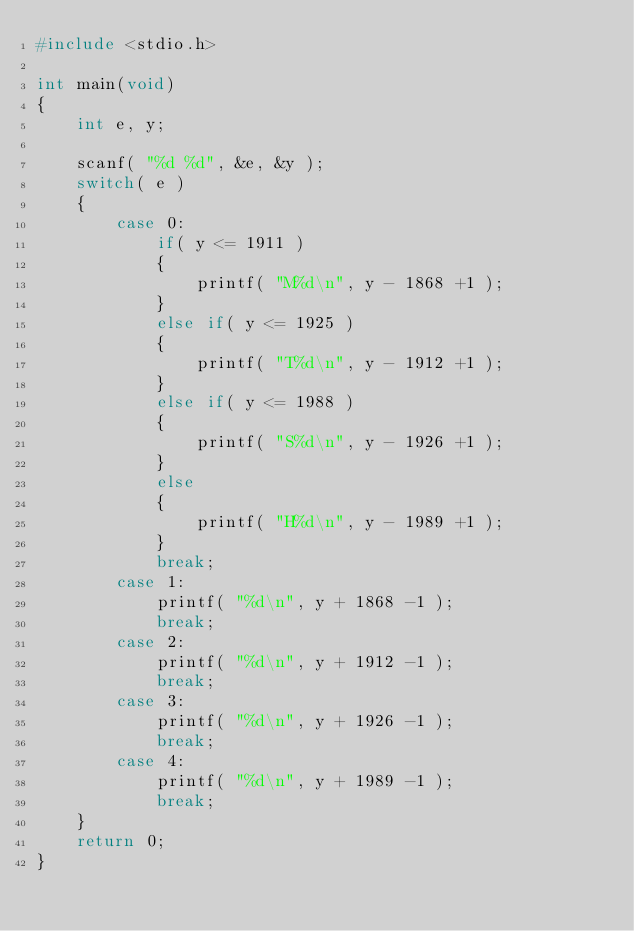<code> <loc_0><loc_0><loc_500><loc_500><_C_>#include <stdio.h>

int main(void)
{
	int e, y;
	
	scanf( "%d %d", &e, &y );
	switch( e )
	{
		case 0:
			if( y <= 1911 )
			{
				printf( "M%d\n", y - 1868 +1 );
			}
			else if( y <= 1925 )
			{
				printf( "T%d\n", y - 1912 +1 );
			}
			else if( y <= 1988 )
			{
				printf( "S%d\n", y - 1926 +1 );
			}
			else
			{
				printf( "H%d\n", y - 1989 +1 );
			}
			break;
		case 1:
			printf( "%d\n", y + 1868 -1 );
			break;
		case 2:
			printf( "%d\n", y + 1912 -1 );
			break;
		case 3:
			printf( "%d\n", y + 1926 -1 );
			break;
		case 4:
			printf( "%d\n", y + 1989 -1 );
			break;
	}
	return 0;
}

</code> 